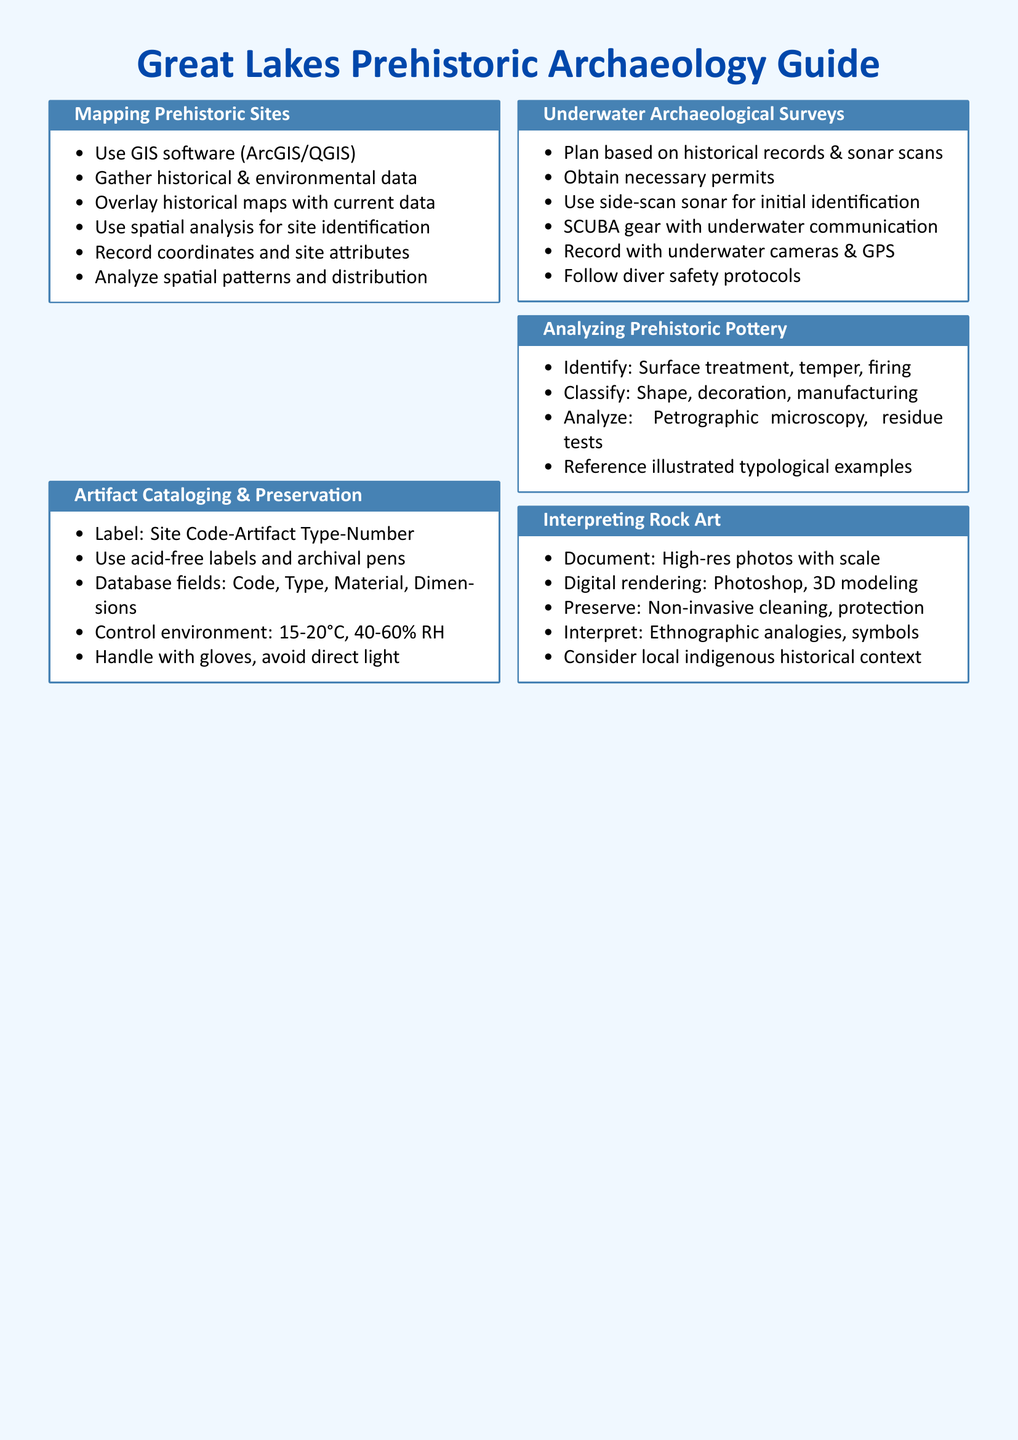What software is recommended for mapping prehistoric sites? The document suggests using GIS software, specifically ArcGIS or QGIS.
Answer: ArcGIS/QGIS What is the recommended temperature range for artifact preservation? The document states that the ideal control environment temperature is between 15 to 20 degrees Celsius.
Answer: 15-20°C What is the first step in planning an underwater archaeological survey? According to the document, the first step is to base the plan on historical records and sonar scans.
Answer: Historical records & sonar scans What cleaning method is advised for preserving rock art? The document recommends using non-invasive cleaning methods to preserve rock art effectively.
Answer: Non-invasive cleaning What classification aspect is suggested for analyzing prehistoric pottery? The document outlines that classification should consider shape as one of the aspects for analyzing pottery.
Answer: Shape How should artifacts be labeled according to the document? The document specifies a labeling format as Site Code-Artifact Type-Number.
Answer: Site Code-Artifact Type-Number What equipment is mentioned for underwater documentation? The document lists underwater cameras and GPS as the equipment for recording during surveys.
Answer: Underwater cameras & GPS How is rock art interpretation guided in the document? The document advises interpreting rock art by considering local indigenous historical context.
Answer: Local indigenous historical context 